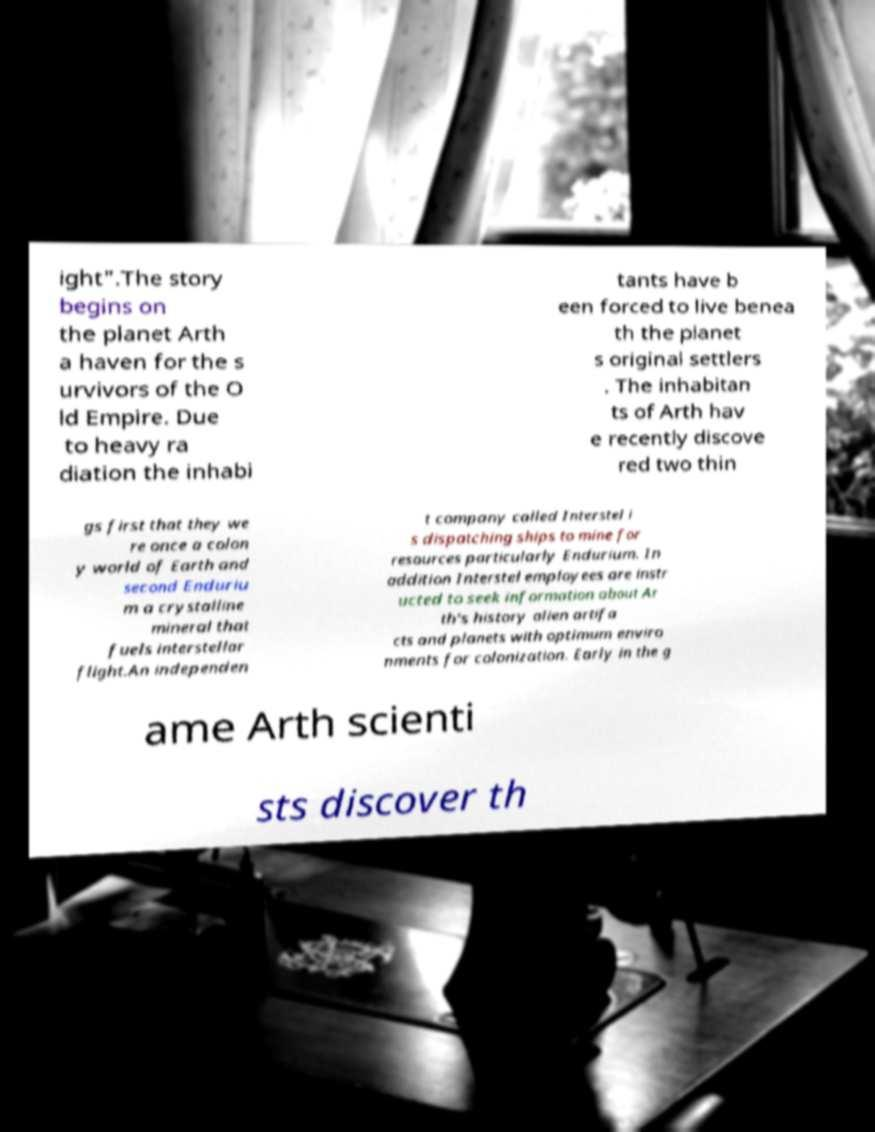Can you accurately transcribe the text from the provided image for me? ight".The story begins on the planet Arth a haven for the s urvivors of the O ld Empire. Due to heavy ra diation the inhabi tants have b een forced to live benea th the planet s original settlers . The inhabitan ts of Arth hav e recently discove red two thin gs first that they we re once a colon y world of Earth and second Enduriu m a crystalline mineral that fuels interstellar flight.An independen t company called Interstel i s dispatching ships to mine for resources particularly Endurium. In addition Interstel employees are instr ucted to seek information about Ar th's history alien artifa cts and planets with optimum enviro nments for colonization. Early in the g ame Arth scienti sts discover th 